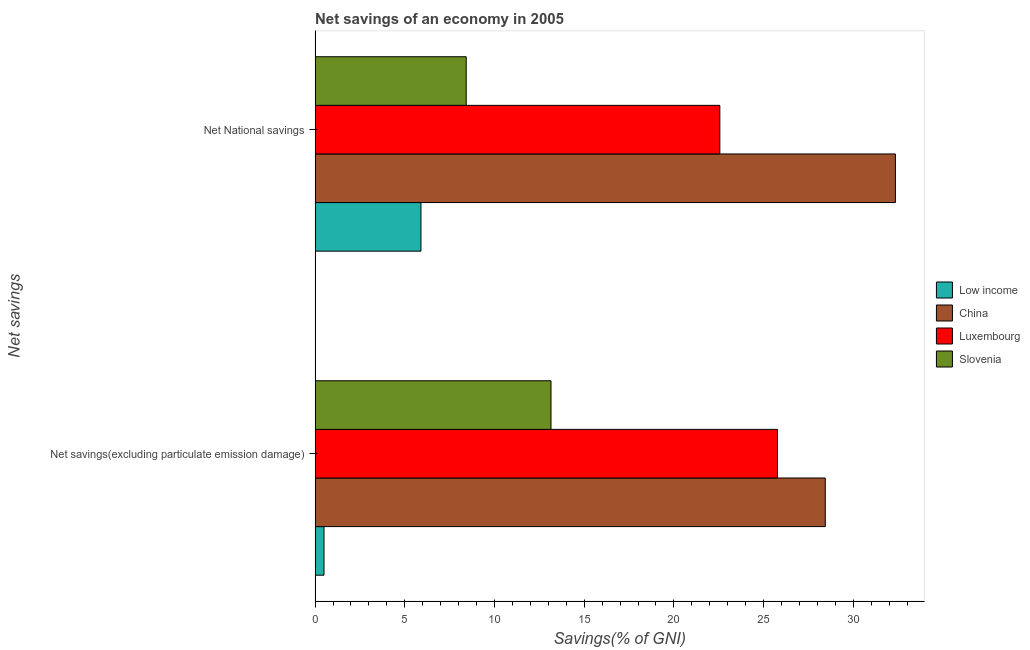How many different coloured bars are there?
Offer a terse response. 4. Are the number of bars per tick equal to the number of legend labels?
Offer a terse response. Yes. What is the label of the 1st group of bars from the top?
Offer a very short reply. Net National savings. What is the net national savings in Slovenia?
Provide a succinct answer. 8.42. Across all countries, what is the maximum net national savings?
Offer a very short reply. 32.34. Across all countries, what is the minimum net savings(excluding particulate emission damage)?
Ensure brevity in your answer.  0.5. In which country was the net national savings minimum?
Give a very brief answer. Low income. What is the total net savings(excluding particulate emission damage) in the graph?
Provide a short and direct response. 67.85. What is the difference between the net savings(excluding particulate emission damage) in Low income and that in Slovenia?
Your answer should be very brief. -12.65. What is the difference between the net national savings in China and the net savings(excluding particulate emission damage) in Slovenia?
Keep it short and to the point. 19.2. What is the average net national savings per country?
Provide a succinct answer. 17.31. What is the difference between the net national savings and net savings(excluding particulate emission damage) in China?
Make the answer very short. 3.91. In how many countries, is the net savings(excluding particulate emission damage) greater than 31 %?
Provide a succinct answer. 0. What is the ratio of the net savings(excluding particulate emission damage) in Luxembourg to that in Low income?
Keep it short and to the point. 51.96. In how many countries, is the net national savings greater than the average net national savings taken over all countries?
Provide a succinct answer. 2. What does the 3rd bar from the bottom in Net National savings represents?
Offer a terse response. Luxembourg. Are all the bars in the graph horizontal?
Offer a terse response. Yes. How many countries are there in the graph?
Your answer should be very brief. 4. What is the difference between two consecutive major ticks on the X-axis?
Keep it short and to the point. 5. Are the values on the major ticks of X-axis written in scientific E-notation?
Your answer should be very brief. No. Does the graph contain any zero values?
Offer a terse response. No. Where does the legend appear in the graph?
Your answer should be compact. Center right. How many legend labels are there?
Your answer should be compact. 4. How are the legend labels stacked?
Give a very brief answer. Vertical. What is the title of the graph?
Make the answer very short. Net savings of an economy in 2005. What is the label or title of the X-axis?
Ensure brevity in your answer.  Savings(% of GNI). What is the label or title of the Y-axis?
Keep it short and to the point. Net savings. What is the Savings(% of GNI) of Low income in Net savings(excluding particulate emission damage)?
Offer a very short reply. 0.5. What is the Savings(% of GNI) of China in Net savings(excluding particulate emission damage)?
Offer a very short reply. 28.44. What is the Savings(% of GNI) in Luxembourg in Net savings(excluding particulate emission damage)?
Provide a succinct answer. 25.77. What is the Savings(% of GNI) of Slovenia in Net savings(excluding particulate emission damage)?
Provide a short and direct response. 13.15. What is the Savings(% of GNI) of Low income in Net National savings?
Give a very brief answer. 5.9. What is the Savings(% of GNI) of China in Net National savings?
Offer a very short reply. 32.34. What is the Savings(% of GNI) in Luxembourg in Net National savings?
Your response must be concise. 22.56. What is the Savings(% of GNI) in Slovenia in Net National savings?
Offer a very short reply. 8.42. Across all Net savings, what is the maximum Savings(% of GNI) in Low income?
Provide a short and direct response. 5.9. Across all Net savings, what is the maximum Savings(% of GNI) in China?
Provide a short and direct response. 32.34. Across all Net savings, what is the maximum Savings(% of GNI) in Luxembourg?
Provide a short and direct response. 25.77. Across all Net savings, what is the maximum Savings(% of GNI) in Slovenia?
Make the answer very short. 13.15. Across all Net savings, what is the minimum Savings(% of GNI) of Low income?
Offer a terse response. 0.5. Across all Net savings, what is the minimum Savings(% of GNI) in China?
Give a very brief answer. 28.44. Across all Net savings, what is the minimum Savings(% of GNI) in Luxembourg?
Provide a succinct answer. 22.56. Across all Net savings, what is the minimum Savings(% of GNI) of Slovenia?
Your answer should be very brief. 8.42. What is the total Savings(% of GNI) in Low income in the graph?
Provide a short and direct response. 6.4. What is the total Savings(% of GNI) in China in the graph?
Your answer should be very brief. 60.78. What is the total Savings(% of GNI) of Luxembourg in the graph?
Provide a short and direct response. 48.33. What is the total Savings(% of GNI) in Slovenia in the graph?
Offer a terse response. 21.57. What is the difference between the Savings(% of GNI) in Low income in Net savings(excluding particulate emission damage) and that in Net National savings?
Make the answer very short. -5.4. What is the difference between the Savings(% of GNI) of China in Net savings(excluding particulate emission damage) and that in Net National savings?
Give a very brief answer. -3.91. What is the difference between the Savings(% of GNI) in Luxembourg in Net savings(excluding particulate emission damage) and that in Net National savings?
Ensure brevity in your answer.  3.21. What is the difference between the Savings(% of GNI) in Slovenia in Net savings(excluding particulate emission damage) and that in Net National savings?
Provide a succinct answer. 4.73. What is the difference between the Savings(% of GNI) of Low income in Net savings(excluding particulate emission damage) and the Savings(% of GNI) of China in Net National savings?
Provide a short and direct response. -31.85. What is the difference between the Savings(% of GNI) in Low income in Net savings(excluding particulate emission damage) and the Savings(% of GNI) in Luxembourg in Net National savings?
Offer a very short reply. -22.06. What is the difference between the Savings(% of GNI) in Low income in Net savings(excluding particulate emission damage) and the Savings(% of GNI) in Slovenia in Net National savings?
Keep it short and to the point. -7.93. What is the difference between the Savings(% of GNI) of China in Net savings(excluding particulate emission damage) and the Savings(% of GNI) of Luxembourg in Net National savings?
Offer a terse response. 5.88. What is the difference between the Savings(% of GNI) of China in Net savings(excluding particulate emission damage) and the Savings(% of GNI) of Slovenia in Net National savings?
Make the answer very short. 20.01. What is the difference between the Savings(% of GNI) of Luxembourg in Net savings(excluding particulate emission damage) and the Savings(% of GNI) of Slovenia in Net National savings?
Keep it short and to the point. 17.35. What is the average Savings(% of GNI) of Low income per Net savings?
Offer a very short reply. 3.2. What is the average Savings(% of GNI) of China per Net savings?
Offer a terse response. 30.39. What is the average Savings(% of GNI) of Luxembourg per Net savings?
Provide a short and direct response. 24.17. What is the average Savings(% of GNI) in Slovenia per Net savings?
Provide a succinct answer. 10.78. What is the difference between the Savings(% of GNI) of Low income and Savings(% of GNI) of China in Net savings(excluding particulate emission damage)?
Offer a very short reply. -27.94. What is the difference between the Savings(% of GNI) of Low income and Savings(% of GNI) of Luxembourg in Net savings(excluding particulate emission damage)?
Offer a terse response. -25.28. What is the difference between the Savings(% of GNI) in Low income and Savings(% of GNI) in Slovenia in Net savings(excluding particulate emission damage)?
Provide a succinct answer. -12.65. What is the difference between the Savings(% of GNI) of China and Savings(% of GNI) of Luxembourg in Net savings(excluding particulate emission damage)?
Your answer should be compact. 2.66. What is the difference between the Savings(% of GNI) in China and Savings(% of GNI) in Slovenia in Net savings(excluding particulate emission damage)?
Keep it short and to the point. 15.29. What is the difference between the Savings(% of GNI) in Luxembourg and Savings(% of GNI) in Slovenia in Net savings(excluding particulate emission damage)?
Offer a very short reply. 12.62. What is the difference between the Savings(% of GNI) in Low income and Savings(% of GNI) in China in Net National savings?
Your answer should be very brief. -26.44. What is the difference between the Savings(% of GNI) of Low income and Savings(% of GNI) of Luxembourg in Net National savings?
Your answer should be very brief. -16.66. What is the difference between the Savings(% of GNI) of Low income and Savings(% of GNI) of Slovenia in Net National savings?
Your answer should be compact. -2.52. What is the difference between the Savings(% of GNI) in China and Savings(% of GNI) in Luxembourg in Net National savings?
Give a very brief answer. 9.79. What is the difference between the Savings(% of GNI) in China and Savings(% of GNI) in Slovenia in Net National savings?
Keep it short and to the point. 23.92. What is the difference between the Savings(% of GNI) in Luxembourg and Savings(% of GNI) in Slovenia in Net National savings?
Your answer should be compact. 14.14. What is the ratio of the Savings(% of GNI) of Low income in Net savings(excluding particulate emission damage) to that in Net National savings?
Ensure brevity in your answer.  0.08. What is the ratio of the Savings(% of GNI) of China in Net savings(excluding particulate emission damage) to that in Net National savings?
Provide a succinct answer. 0.88. What is the ratio of the Savings(% of GNI) in Luxembourg in Net savings(excluding particulate emission damage) to that in Net National savings?
Your response must be concise. 1.14. What is the ratio of the Savings(% of GNI) of Slovenia in Net savings(excluding particulate emission damage) to that in Net National savings?
Keep it short and to the point. 1.56. What is the difference between the highest and the second highest Savings(% of GNI) of Low income?
Offer a terse response. 5.4. What is the difference between the highest and the second highest Savings(% of GNI) in China?
Your answer should be compact. 3.91. What is the difference between the highest and the second highest Savings(% of GNI) of Luxembourg?
Offer a terse response. 3.21. What is the difference between the highest and the second highest Savings(% of GNI) of Slovenia?
Ensure brevity in your answer.  4.73. What is the difference between the highest and the lowest Savings(% of GNI) in Low income?
Keep it short and to the point. 5.4. What is the difference between the highest and the lowest Savings(% of GNI) in China?
Offer a very short reply. 3.91. What is the difference between the highest and the lowest Savings(% of GNI) in Luxembourg?
Your response must be concise. 3.21. What is the difference between the highest and the lowest Savings(% of GNI) of Slovenia?
Give a very brief answer. 4.73. 